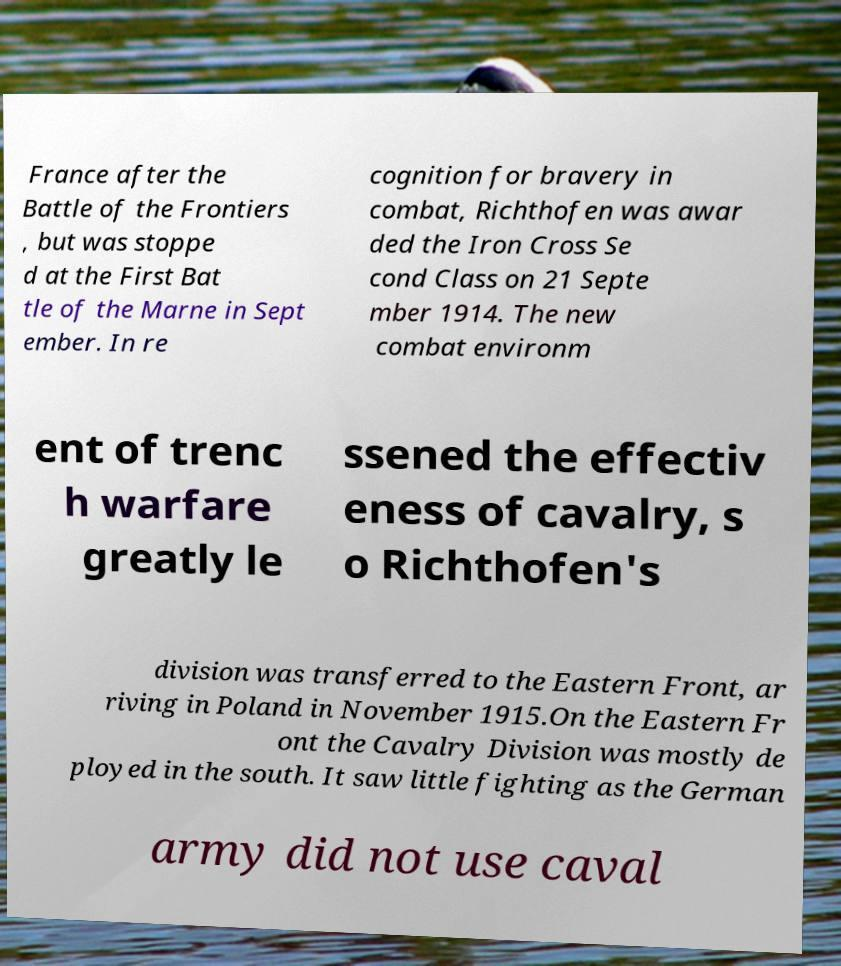Please identify and transcribe the text found in this image. France after the Battle of the Frontiers , but was stoppe d at the First Bat tle of the Marne in Sept ember. In re cognition for bravery in combat, Richthofen was awar ded the Iron Cross Se cond Class on 21 Septe mber 1914. The new combat environm ent of trenc h warfare greatly le ssened the effectiv eness of cavalry, s o Richthofen's division was transferred to the Eastern Front, ar riving in Poland in November 1915.On the Eastern Fr ont the Cavalry Division was mostly de ployed in the south. It saw little fighting as the German army did not use caval 